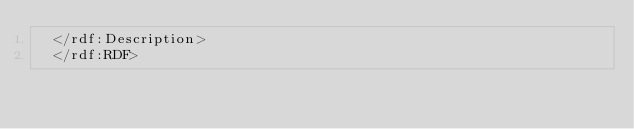<code> <loc_0><loc_0><loc_500><loc_500><_XML_>  </rdf:Description>
  </rdf:RDF></code> 